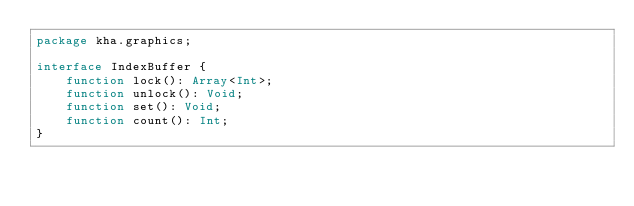Convert code to text. <code><loc_0><loc_0><loc_500><loc_500><_Haxe_>package kha.graphics;

interface IndexBuffer {
	function lock(): Array<Int>;
	function unlock(): Void;
	function set(): Void;
	function count(): Int;
}
</code> 